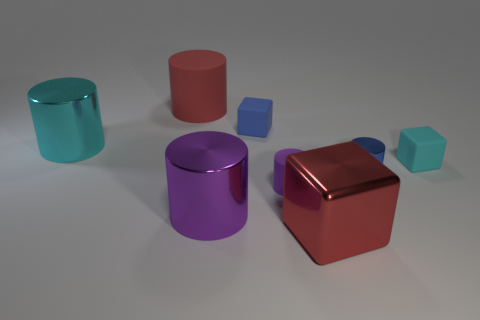Can you describe the arrangement of objects and their colors? Certainly! There are five objects in the image: three cylinders and two cubes. Starting from the left, there is a teal cylinder, a red cylinder, two blue cubes, and a larger burgundy cube. The objects are arranged on a flat surface, and their positioning seems random, with no apparent pattern in the arrangement. 